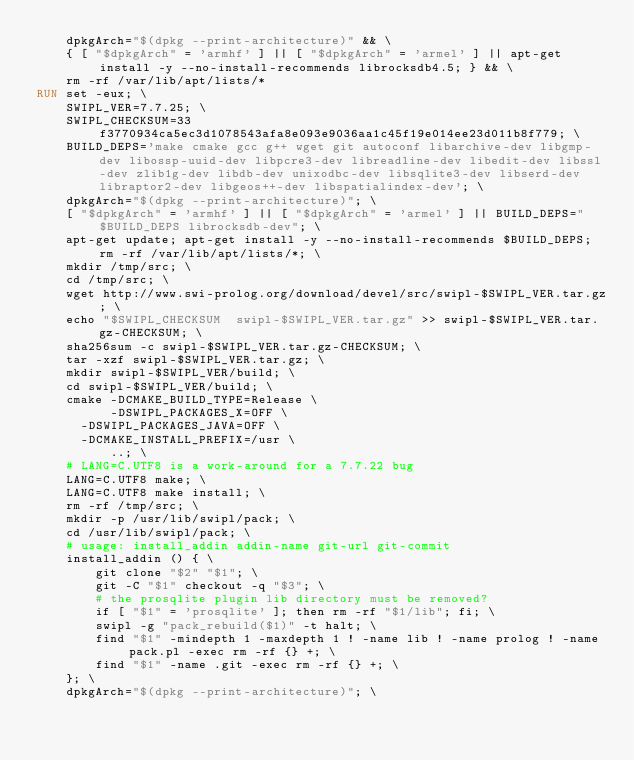Convert code to text. <code><loc_0><loc_0><loc_500><loc_500><_Dockerfile_>    dpkgArch="$(dpkg --print-architecture)" && \
    { [ "$dpkgArch" = 'armhf' ] || [ "$dpkgArch" = 'armel' ] || apt-get install -y --no-install-recommends librocksdb4.5; } && \
    rm -rf /var/lib/apt/lists/*
RUN set -eux; \
    SWIPL_VER=7.7.25; \
    SWIPL_CHECKSUM=33f3770934ca5ec3d1078543afa8e093e9036aa1c45f19e014ee23d011b8f779; \
    BUILD_DEPS='make cmake gcc g++ wget git autoconf libarchive-dev libgmp-dev libossp-uuid-dev libpcre3-dev libreadline-dev libedit-dev libssl-dev zlib1g-dev libdb-dev unixodbc-dev libsqlite3-dev libserd-dev libraptor2-dev libgeos++-dev libspatialindex-dev'; \
    dpkgArch="$(dpkg --print-architecture)"; \
    [ "$dpkgArch" = 'armhf' ] || [ "$dpkgArch" = 'armel' ] || BUILD_DEPS="$BUILD_DEPS librocksdb-dev"; \
    apt-get update; apt-get install -y --no-install-recommends $BUILD_DEPS; rm -rf /var/lib/apt/lists/*; \
    mkdir /tmp/src; \
    cd /tmp/src; \
    wget http://www.swi-prolog.org/download/devel/src/swipl-$SWIPL_VER.tar.gz; \
    echo "$SWIPL_CHECKSUM  swipl-$SWIPL_VER.tar.gz" >> swipl-$SWIPL_VER.tar.gz-CHECKSUM; \
    sha256sum -c swipl-$SWIPL_VER.tar.gz-CHECKSUM; \
    tar -xzf swipl-$SWIPL_VER.tar.gz; \
    mkdir swipl-$SWIPL_VER/build; \
    cd swipl-$SWIPL_VER/build; \
    cmake -DCMAKE_BUILD_TYPE=Release \
          -DSWIPL_PACKAGES_X=OFF \
	  -DSWIPL_PACKAGES_JAVA=OFF \
	  -DCMAKE_INSTALL_PREFIX=/usr \
          ..; \
    # LANG=C.UTF8 is a work-around for a 7.7.22 bug
    LANG=C.UTF8 make; \
    LANG=C.UTF8 make install; \
    rm -rf /tmp/src; \
    mkdir -p /usr/lib/swipl/pack; \
    cd /usr/lib/swipl/pack; \
    # usage: install_addin addin-name git-url git-commit
    install_addin () { \
        git clone "$2" "$1"; \
        git -C "$1" checkout -q "$3"; \
        # the prosqlite plugin lib directory must be removed?
        if [ "$1" = 'prosqlite' ]; then rm -rf "$1/lib"; fi; \
        swipl -g "pack_rebuild($1)" -t halt; \
        find "$1" -mindepth 1 -maxdepth 1 ! -name lib ! -name prolog ! -name pack.pl -exec rm -rf {} +; \
        find "$1" -name .git -exec rm -rf {} +; \
    }; \
    dpkgArch="$(dpkg --print-architecture)"; \</code> 